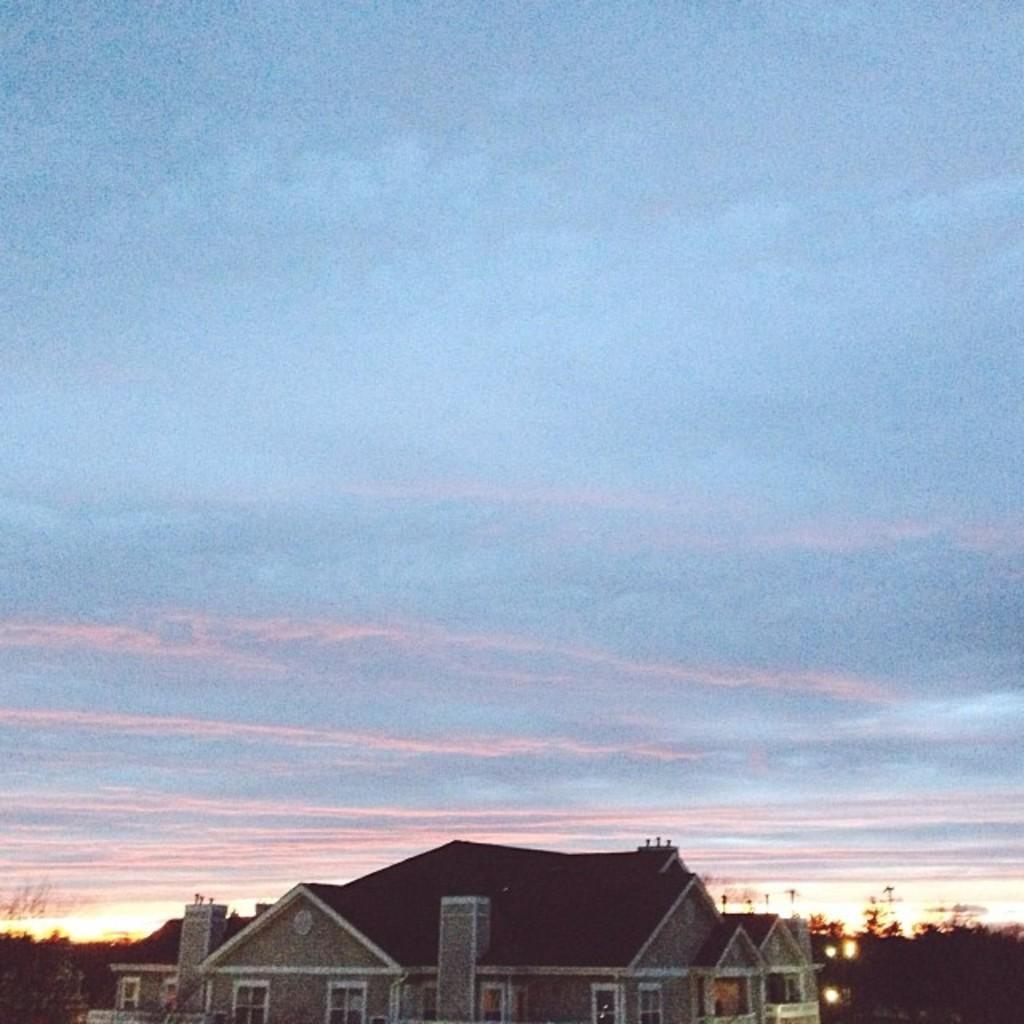What is located at the bottom of the image? There is a building and trees at the bottom of the image. What can be seen illuminated in the image? There are lights visible in the image. What is visible at the top of the image? The sky is visible at the top of the image. What type of juice can be seen being poured by the spiders in the image? There are no spiders or juice present in the image. What type of playground equipment can be seen in the image? There is no playground equipment present in the image. 